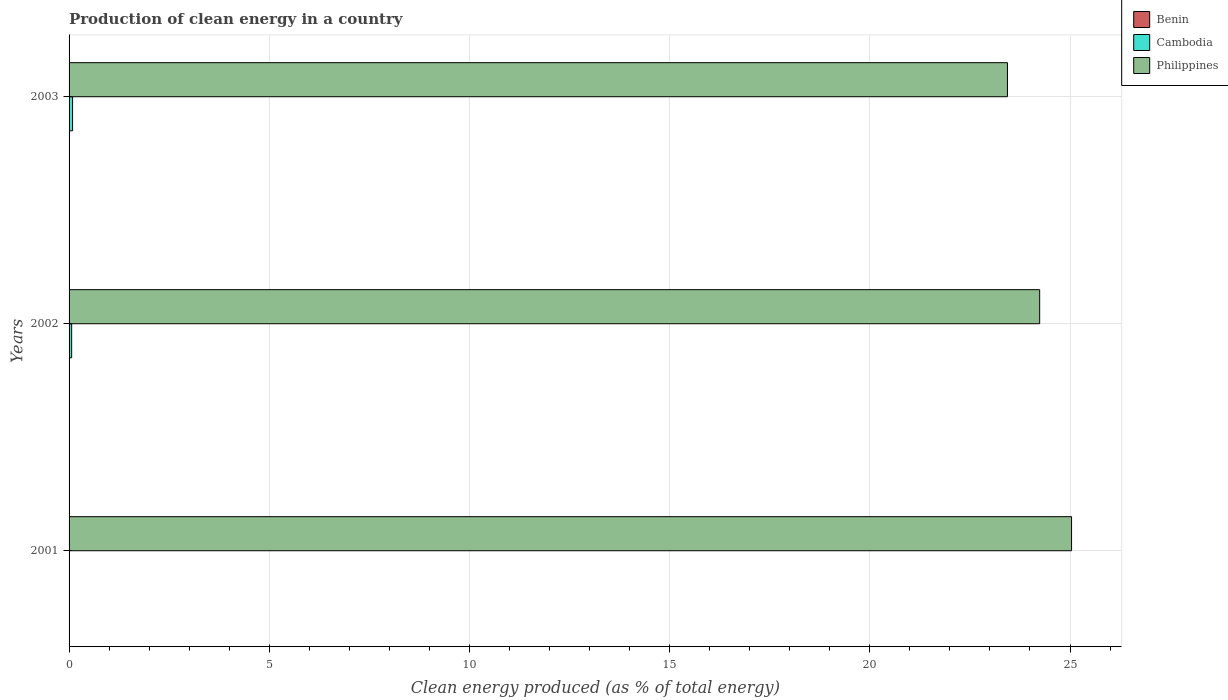Are the number of bars per tick equal to the number of legend labels?
Keep it short and to the point. Yes. Are the number of bars on each tick of the Y-axis equal?
Your answer should be compact. Yes. What is the percentage of clean energy produced in Philippines in 2001?
Provide a succinct answer. 25.04. Across all years, what is the maximum percentage of clean energy produced in Cambodia?
Offer a terse response. 0.09. Across all years, what is the minimum percentage of clean energy produced in Cambodia?
Your answer should be very brief. 0. In which year was the percentage of clean energy produced in Philippines maximum?
Make the answer very short. 2001. What is the total percentage of clean energy produced in Benin in the graph?
Give a very brief answer. 0.02. What is the difference between the percentage of clean energy produced in Benin in 2001 and that in 2003?
Your answer should be very brief. 0. What is the difference between the percentage of clean energy produced in Benin in 2003 and the percentage of clean energy produced in Philippines in 2002?
Offer a terse response. -24.24. What is the average percentage of clean energy produced in Philippines per year?
Your answer should be compact. 24.24. In the year 2001, what is the difference between the percentage of clean energy produced in Benin and percentage of clean energy produced in Cambodia?
Give a very brief answer. 0.01. In how many years, is the percentage of clean energy produced in Philippines greater than 6 %?
Provide a short and direct response. 3. What is the ratio of the percentage of clean energy produced in Cambodia in 2001 to that in 2002?
Provide a short and direct response. 0.04. What is the difference between the highest and the second highest percentage of clean energy produced in Benin?
Offer a very short reply. 0. What is the difference between the highest and the lowest percentage of clean energy produced in Philippines?
Offer a very short reply. 1.6. In how many years, is the percentage of clean energy produced in Benin greater than the average percentage of clean energy produced in Benin taken over all years?
Ensure brevity in your answer.  1. Is the sum of the percentage of clean energy produced in Philippines in 2001 and 2003 greater than the maximum percentage of clean energy produced in Benin across all years?
Give a very brief answer. Yes. Is it the case that in every year, the sum of the percentage of clean energy produced in Cambodia and percentage of clean energy produced in Benin is greater than the percentage of clean energy produced in Philippines?
Ensure brevity in your answer.  No. How many bars are there?
Your answer should be very brief. 9. What is the difference between two consecutive major ticks on the X-axis?
Your answer should be compact. 5. Does the graph contain any zero values?
Make the answer very short. No. Does the graph contain grids?
Provide a short and direct response. Yes. Where does the legend appear in the graph?
Offer a terse response. Top right. How are the legend labels stacked?
Offer a terse response. Vertical. What is the title of the graph?
Your response must be concise. Production of clean energy in a country. What is the label or title of the X-axis?
Make the answer very short. Clean energy produced (as % of total energy). What is the Clean energy produced (as % of total energy) of Benin in 2001?
Your answer should be compact. 0.01. What is the Clean energy produced (as % of total energy) in Cambodia in 2001?
Make the answer very short. 0. What is the Clean energy produced (as % of total energy) of Philippines in 2001?
Provide a short and direct response. 25.04. What is the Clean energy produced (as % of total energy) in Benin in 2002?
Keep it short and to the point. 0.01. What is the Clean energy produced (as % of total energy) of Cambodia in 2002?
Provide a short and direct response. 0.06. What is the Clean energy produced (as % of total energy) in Philippines in 2002?
Keep it short and to the point. 24.24. What is the Clean energy produced (as % of total energy) of Benin in 2003?
Your response must be concise. 0.01. What is the Clean energy produced (as % of total energy) of Cambodia in 2003?
Your answer should be very brief. 0.09. What is the Clean energy produced (as % of total energy) of Philippines in 2003?
Offer a very short reply. 23.44. Across all years, what is the maximum Clean energy produced (as % of total energy) of Benin?
Keep it short and to the point. 0.01. Across all years, what is the maximum Clean energy produced (as % of total energy) of Cambodia?
Offer a very short reply. 0.09. Across all years, what is the maximum Clean energy produced (as % of total energy) of Philippines?
Your answer should be compact. 25.04. Across all years, what is the minimum Clean energy produced (as % of total energy) of Benin?
Your answer should be very brief. 0.01. Across all years, what is the minimum Clean energy produced (as % of total energy) of Cambodia?
Ensure brevity in your answer.  0. Across all years, what is the minimum Clean energy produced (as % of total energy) of Philippines?
Make the answer very short. 23.44. What is the total Clean energy produced (as % of total energy) in Benin in the graph?
Ensure brevity in your answer.  0.02. What is the total Clean energy produced (as % of total energy) in Cambodia in the graph?
Offer a terse response. 0.15. What is the total Clean energy produced (as % of total energy) in Philippines in the graph?
Make the answer very short. 72.72. What is the difference between the Clean energy produced (as % of total energy) in Benin in 2001 and that in 2002?
Give a very brief answer. 0. What is the difference between the Clean energy produced (as % of total energy) of Cambodia in 2001 and that in 2002?
Keep it short and to the point. -0.06. What is the difference between the Clean energy produced (as % of total energy) of Philippines in 2001 and that in 2002?
Offer a very short reply. 0.8. What is the difference between the Clean energy produced (as % of total energy) of Benin in 2001 and that in 2003?
Your answer should be compact. 0. What is the difference between the Clean energy produced (as % of total energy) in Cambodia in 2001 and that in 2003?
Provide a short and direct response. -0.09. What is the difference between the Clean energy produced (as % of total energy) in Philippines in 2001 and that in 2003?
Provide a succinct answer. 1.6. What is the difference between the Clean energy produced (as % of total energy) in Benin in 2002 and that in 2003?
Provide a succinct answer. 0. What is the difference between the Clean energy produced (as % of total energy) in Cambodia in 2002 and that in 2003?
Ensure brevity in your answer.  -0.02. What is the difference between the Clean energy produced (as % of total energy) in Philippines in 2002 and that in 2003?
Keep it short and to the point. 0.8. What is the difference between the Clean energy produced (as % of total energy) in Benin in 2001 and the Clean energy produced (as % of total energy) in Cambodia in 2002?
Make the answer very short. -0.06. What is the difference between the Clean energy produced (as % of total energy) in Benin in 2001 and the Clean energy produced (as % of total energy) in Philippines in 2002?
Provide a succinct answer. -24.23. What is the difference between the Clean energy produced (as % of total energy) in Cambodia in 2001 and the Clean energy produced (as % of total energy) in Philippines in 2002?
Ensure brevity in your answer.  -24.24. What is the difference between the Clean energy produced (as % of total energy) of Benin in 2001 and the Clean energy produced (as % of total energy) of Cambodia in 2003?
Give a very brief answer. -0.08. What is the difference between the Clean energy produced (as % of total energy) in Benin in 2001 and the Clean energy produced (as % of total energy) in Philippines in 2003?
Give a very brief answer. -23.43. What is the difference between the Clean energy produced (as % of total energy) of Cambodia in 2001 and the Clean energy produced (as % of total energy) of Philippines in 2003?
Provide a short and direct response. -23.44. What is the difference between the Clean energy produced (as % of total energy) of Benin in 2002 and the Clean energy produced (as % of total energy) of Cambodia in 2003?
Your response must be concise. -0.08. What is the difference between the Clean energy produced (as % of total energy) of Benin in 2002 and the Clean energy produced (as % of total energy) of Philippines in 2003?
Give a very brief answer. -23.43. What is the difference between the Clean energy produced (as % of total energy) in Cambodia in 2002 and the Clean energy produced (as % of total energy) in Philippines in 2003?
Keep it short and to the point. -23.37. What is the average Clean energy produced (as % of total energy) of Benin per year?
Make the answer very short. 0.01. What is the average Clean energy produced (as % of total energy) in Cambodia per year?
Offer a terse response. 0.05. What is the average Clean energy produced (as % of total energy) of Philippines per year?
Your answer should be very brief. 24.24. In the year 2001, what is the difference between the Clean energy produced (as % of total energy) of Benin and Clean energy produced (as % of total energy) of Cambodia?
Provide a short and direct response. 0.01. In the year 2001, what is the difference between the Clean energy produced (as % of total energy) of Benin and Clean energy produced (as % of total energy) of Philippines?
Your response must be concise. -25.03. In the year 2001, what is the difference between the Clean energy produced (as % of total energy) in Cambodia and Clean energy produced (as % of total energy) in Philippines?
Keep it short and to the point. -25.04. In the year 2002, what is the difference between the Clean energy produced (as % of total energy) in Benin and Clean energy produced (as % of total energy) in Cambodia?
Make the answer very short. -0.06. In the year 2002, what is the difference between the Clean energy produced (as % of total energy) in Benin and Clean energy produced (as % of total energy) in Philippines?
Make the answer very short. -24.23. In the year 2002, what is the difference between the Clean energy produced (as % of total energy) of Cambodia and Clean energy produced (as % of total energy) of Philippines?
Your response must be concise. -24.18. In the year 2003, what is the difference between the Clean energy produced (as % of total energy) of Benin and Clean energy produced (as % of total energy) of Cambodia?
Offer a very short reply. -0.08. In the year 2003, what is the difference between the Clean energy produced (as % of total energy) in Benin and Clean energy produced (as % of total energy) in Philippines?
Your answer should be compact. -23.43. In the year 2003, what is the difference between the Clean energy produced (as % of total energy) of Cambodia and Clean energy produced (as % of total energy) of Philippines?
Give a very brief answer. -23.35. What is the ratio of the Clean energy produced (as % of total energy) in Benin in 2001 to that in 2002?
Your answer should be very brief. 1.07. What is the ratio of the Clean energy produced (as % of total energy) of Cambodia in 2001 to that in 2002?
Provide a short and direct response. 0.04. What is the ratio of the Clean energy produced (as % of total energy) in Philippines in 2001 to that in 2002?
Offer a terse response. 1.03. What is the ratio of the Clean energy produced (as % of total energy) in Benin in 2001 to that in 2003?
Make the answer very short. 1.13. What is the ratio of the Clean energy produced (as % of total energy) in Cambodia in 2001 to that in 2003?
Provide a short and direct response. 0.03. What is the ratio of the Clean energy produced (as % of total energy) of Philippines in 2001 to that in 2003?
Give a very brief answer. 1.07. What is the ratio of the Clean energy produced (as % of total energy) in Benin in 2002 to that in 2003?
Provide a short and direct response. 1.05. What is the ratio of the Clean energy produced (as % of total energy) in Cambodia in 2002 to that in 2003?
Provide a succinct answer. 0.74. What is the ratio of the Clean energy produced (as % of total energy) in Philippines in 2002 to that in 2003?
Make the answer very short. 1.03. What is the difference between the highest and the second highest Clean energy produced (as % of total energy) in Benin?
Give a very brief answer. 0. What is the difference between the highest and the second highest Clean energy produced (as % of total energy) of Cambodia?
Make the answer very short. 0.02. What is the difference between the highest and the second highest Clean energy produced (as % of total energy) in Philippines?
Provide a succinct answer. 0.8. What is the difference between the highest and the lowest Clean energy produced (as % of total energy) in Benin?
Offer a terse response. 0. What is the difference between the highest and the lowest Clean energy produced (as % of total energy) of Cambodia?
Your response must be concise. 0.09. What is the difference between the highest and the lowest Clean energy produced (as % of total energy) of Philippines?
Ensure brevity in your answer.  1.6. 